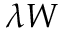Convert formula to latex. <formula><loc_0><loc_0><loc_500><loc_500>\lambda W</formula> 